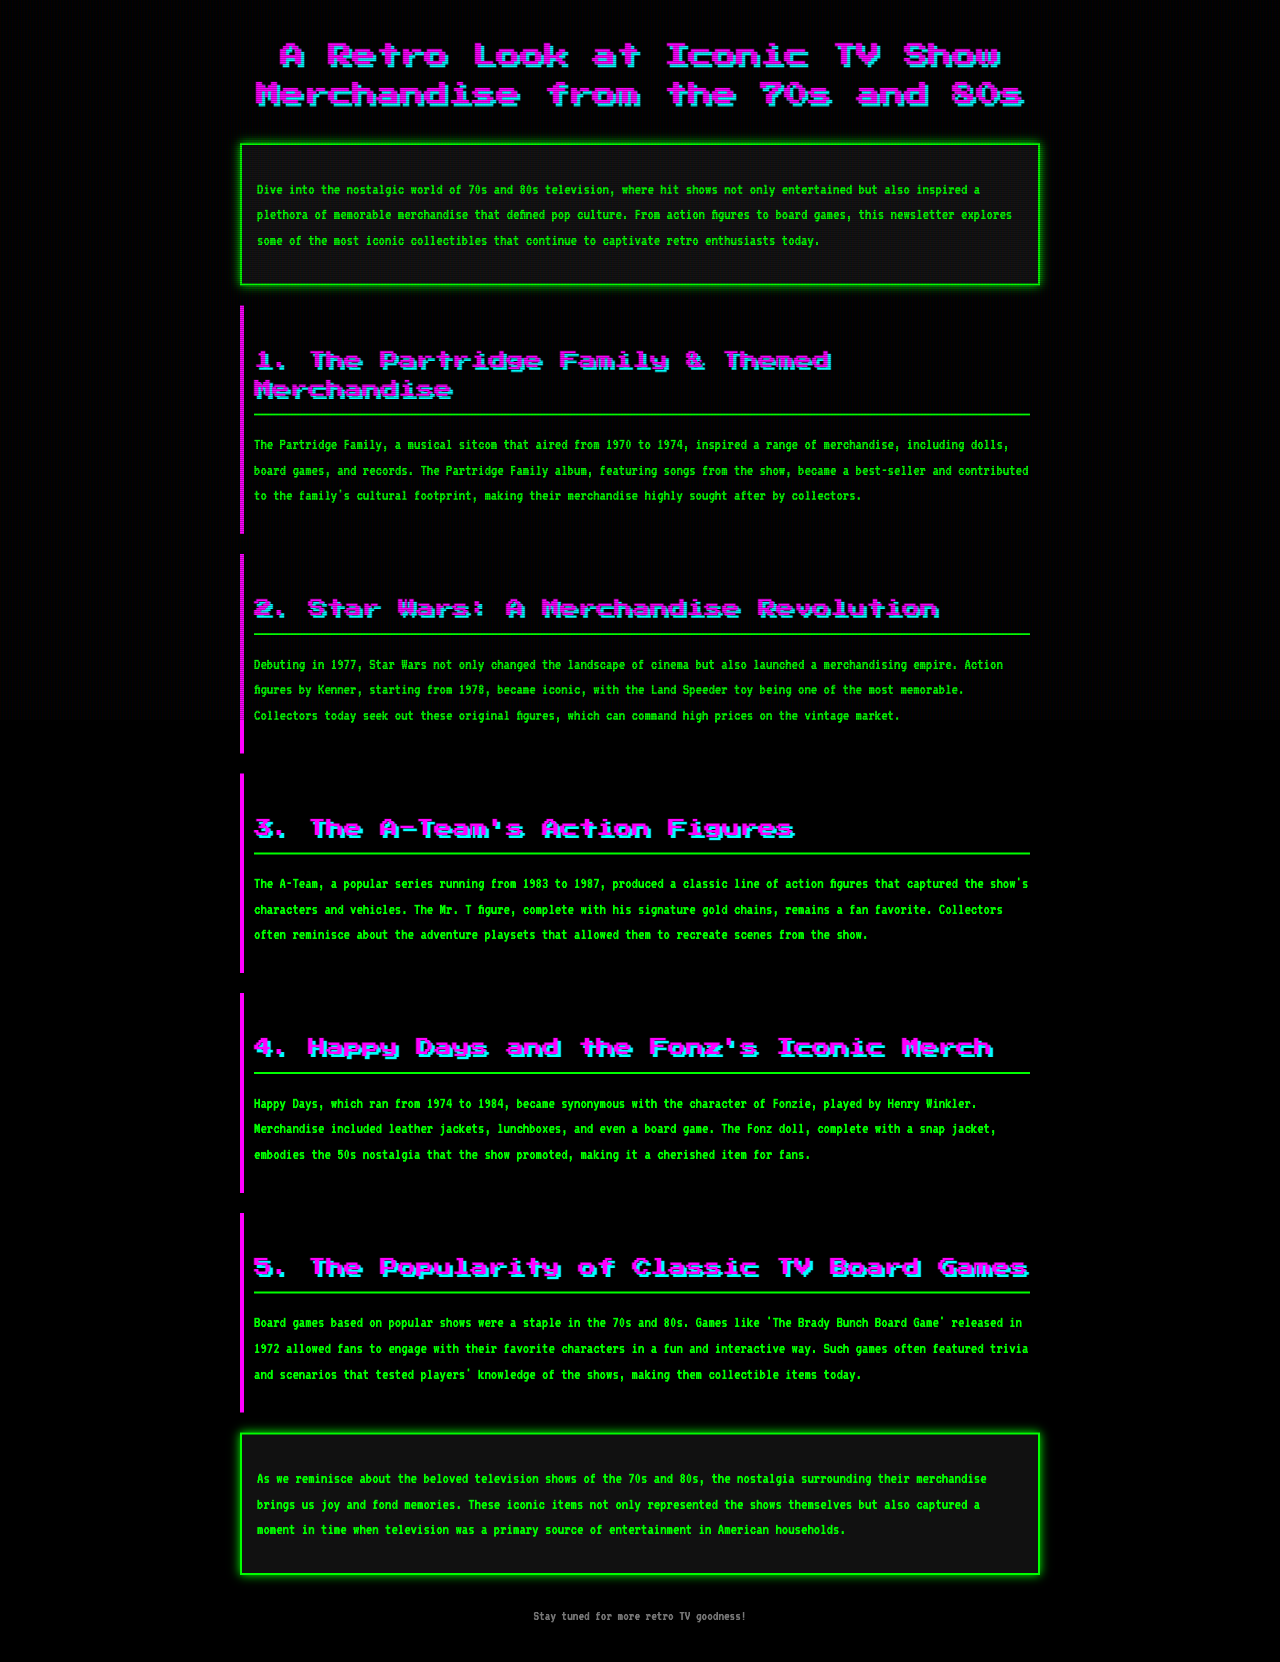What show inspired a range of merchandise including dolls and board games? The document mentions "The Partridge Family," which aired from 1970 to 1974, as a source of various merchandise including dolls and board games.
Answer: The Partridge Family What year did Star Wars debut? According to the document, Star Wars debuted in 1977, marking the beginning of a significant merchandising era.
Answer: 1977 Which character from Happy Days became synonymous with the show? The document states that Fonzie, played by Henry Winkler, became synonymous with Happy Days and its merchandise.
Answer: Fonzie What type of merchandise was associated with The A-Team? The document highlights that The A-Team produced a classic line of action figures, capturing characters and vehicles from the series.
Answer: Action figures What was the name of the board game released in 1972 based on a popular show? The document states that 'The Brady Bunch Board Game' was released in 1972, allowing fans to engage with their favorite characters.
Answer: The Brady Bunch Board Game Why do collectors seek original Star Wars action figures? Original Star Wars action figures from 1978 can command high prices on the vintage market, making them highly sought after by collectors.
Answer: High prices What decade did Happy Days air? The document mentions that Happy Days ran from 1974 to 1984, placing it firmly in the 1970s and 1980s.
Answer: 1970s and 1980s What is the main focus of the newsletter? The newsletter focuses on iconic TV show merchandise from the 70s and 80s, exploring various collectibles.
Answer: Iconic TV show merchandise What type of merchandise is mentioned as a staple in the 70s and 80s? The document indicates that board games based on popular shows were commonly produced during the 70s and 80s.
Answer: Board games 